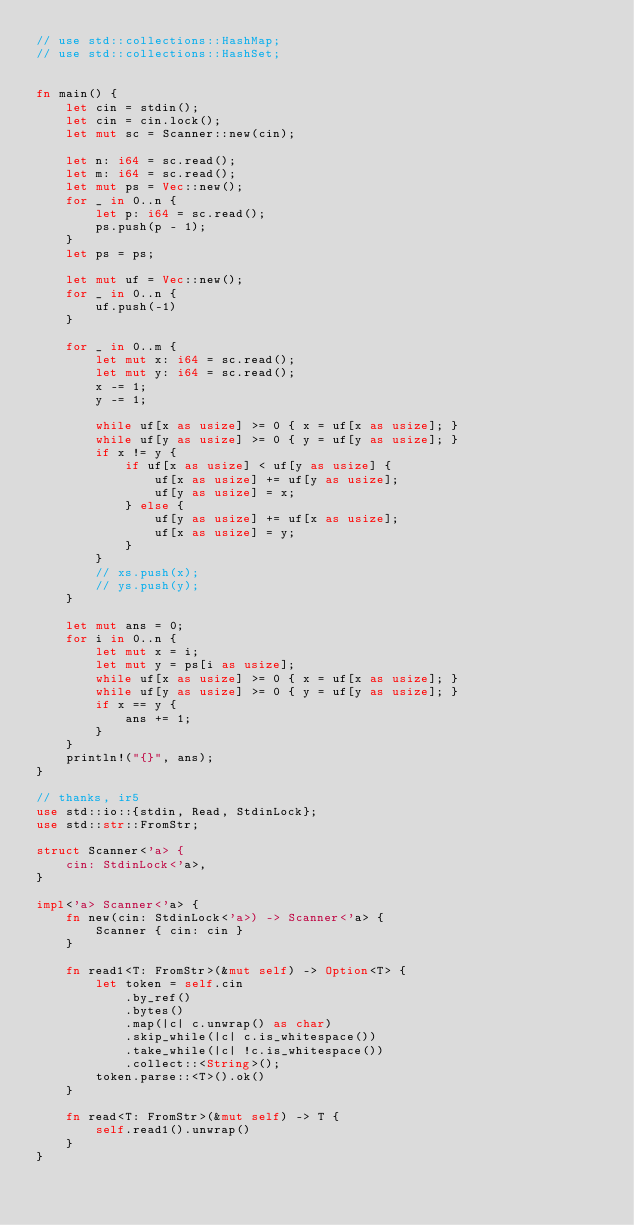Convert code to text. <code><loc_0><loc_0><loc_500><loc_500><_Rust_>// use std::collections::HashMap;
// use std::collections::HashSet;


fn main() {
    let cin = stdin();
    let cin = cin.lock();
    let mut sc = Scanner::new(cin);

    let n: i64 = sc.read();
    let m: i64 = sc.read();
    let mut ps = Vec::new();
    for _ in 0..n {
        let p: i64 = sc.read();
        ps.push(p - 1);
    }
    let ps = ps;

    let mut uf = Vec::new();
    for _ in 0..n {
        uf.push(-1)
    }

    for _ in 0..m {
        let mut x: i64 = sc.read();
        let mut y: i64 = sc.read();
        x -= 1;
        y -= 1;

        while uf[x as usize] >= 0 { x = uf[x as usize]; }
        while uf[y as usize] >= 0 { y = uf[y as usize]; }
        if x != y {
            if uf[x as usize] < uf[y as usize] {
                uf[x as usize] += uf[y as usize];
                uf[y as usize] = x;
            } else {
                uf[y as usize] += uf[x as usize];
                uf[x as usize] = y;
            }
        }
        // xs.push(x);
        // ys.push(y);
    }

    let mut ans = 0;
    for i in 0..n {
        let mut x = i;
        let mut y = ps[i as usize];
        while uf[x as usize] >= 0 { x = uf[x as usize]; }
        while uf[y as usize] >= 0 { y = uf[y as usize]; }
        if x == y {
            ans += 1;
        }
    }
    println!("{}", ans);
}

// thanks, ir5
use std::io::{stdin, Read, StdinLock};
use std::str::FromStr;

struct Scanner<'a> {
    cin: StdinLock<'a>,
}

impl<'a> Scanner<'a> {
    fn new(cin: StdinLock<'a>) -> Scanner<'a> {
        Scanner { cin: cin }
    }

    fn read1<T: FromStr>(&mut self) -> Option<T> {
        let token = self.cin
            .by_ref()
            .bytes()
            .map(|c| c.unwrap() as char)
            .skip_while(|c| c.is_whitespace())
            .take_while(|c| !c.is_whitespace())
            .collect::<String>();
        token.parse::<T>().ok()
    }

    fn read<T: FromStr>(&mut self) -> T {
        self.read1().unwrap()
    }
}
</code> 